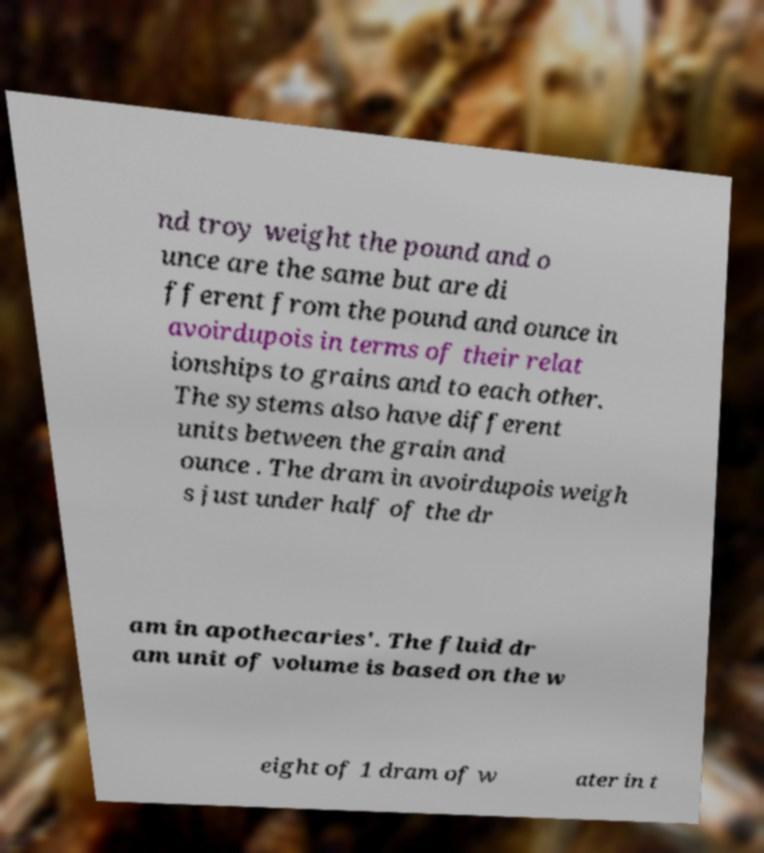Can you accurately transcribe the text from the provided image for me? nd troy weight the pound and o unce are the same but are di fferent from the pound and ounce in avoirdupois in terms of their relat ionships to grains and to each other. The systems also have different units between the grain and ounce . The dram in avoirdupois weigh s just under half of the dr am in apothecaries'. The fluid dr am unit of volume is based on the w eight of 1 dram of w ater in t 